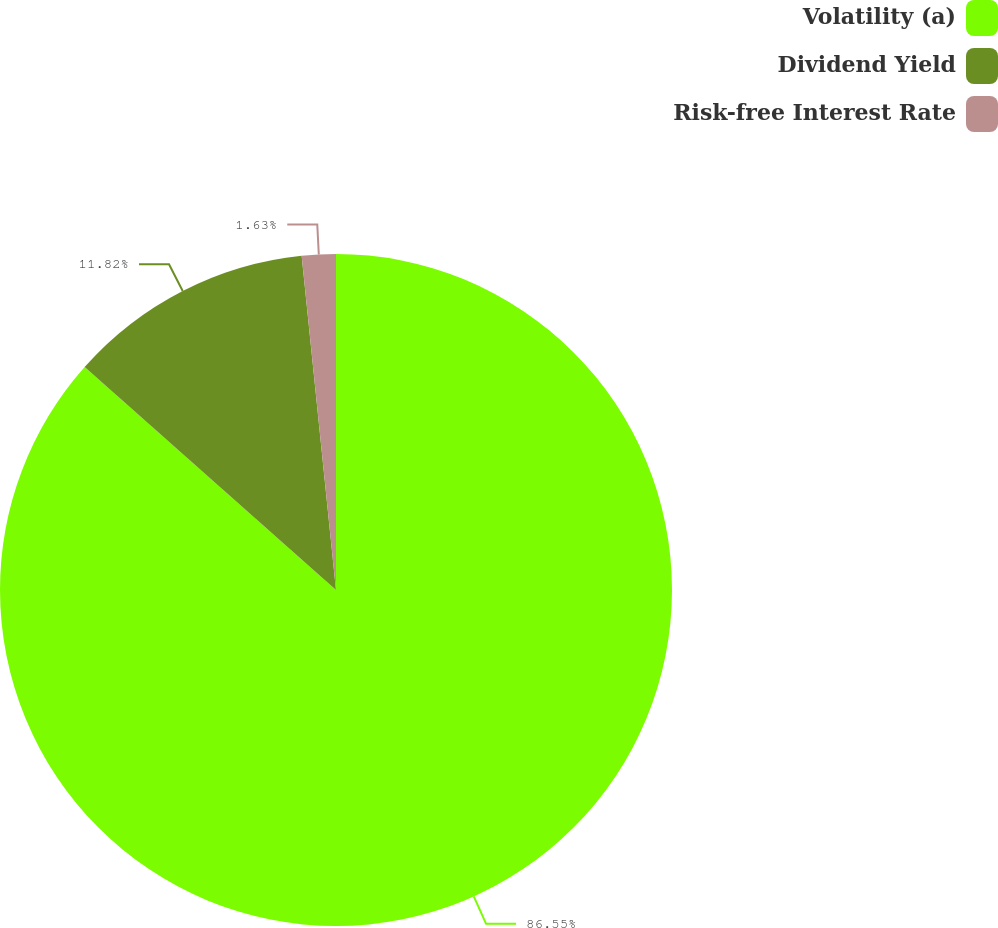Convert chart to OTSL. <chart><loc_0><loc_0><loc_500><loc_500><pie_chart><fcel>Volatility (a)<fcel>Dividend Yield<fcel>Risk-free Interest Rate<nl><fcel>86.55%<fcel>11.82%<fcel>1.63%<nl></chart> 